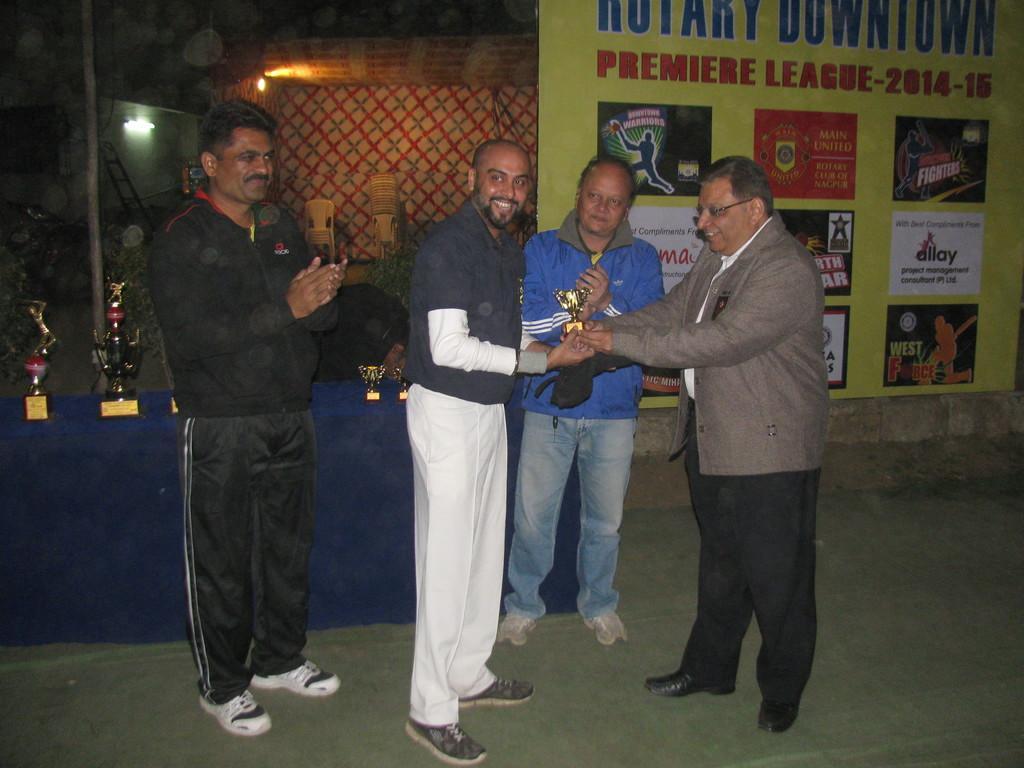How would you summarize this image in a sentence or two? In the front of the image I can see four people are standing. Among them two people are holding a trophy and another two people are clapping their hands. In the background of the image there is a hoarding, table, chairs, tent, lights, ladder, pole, trophies, plant and objects.   